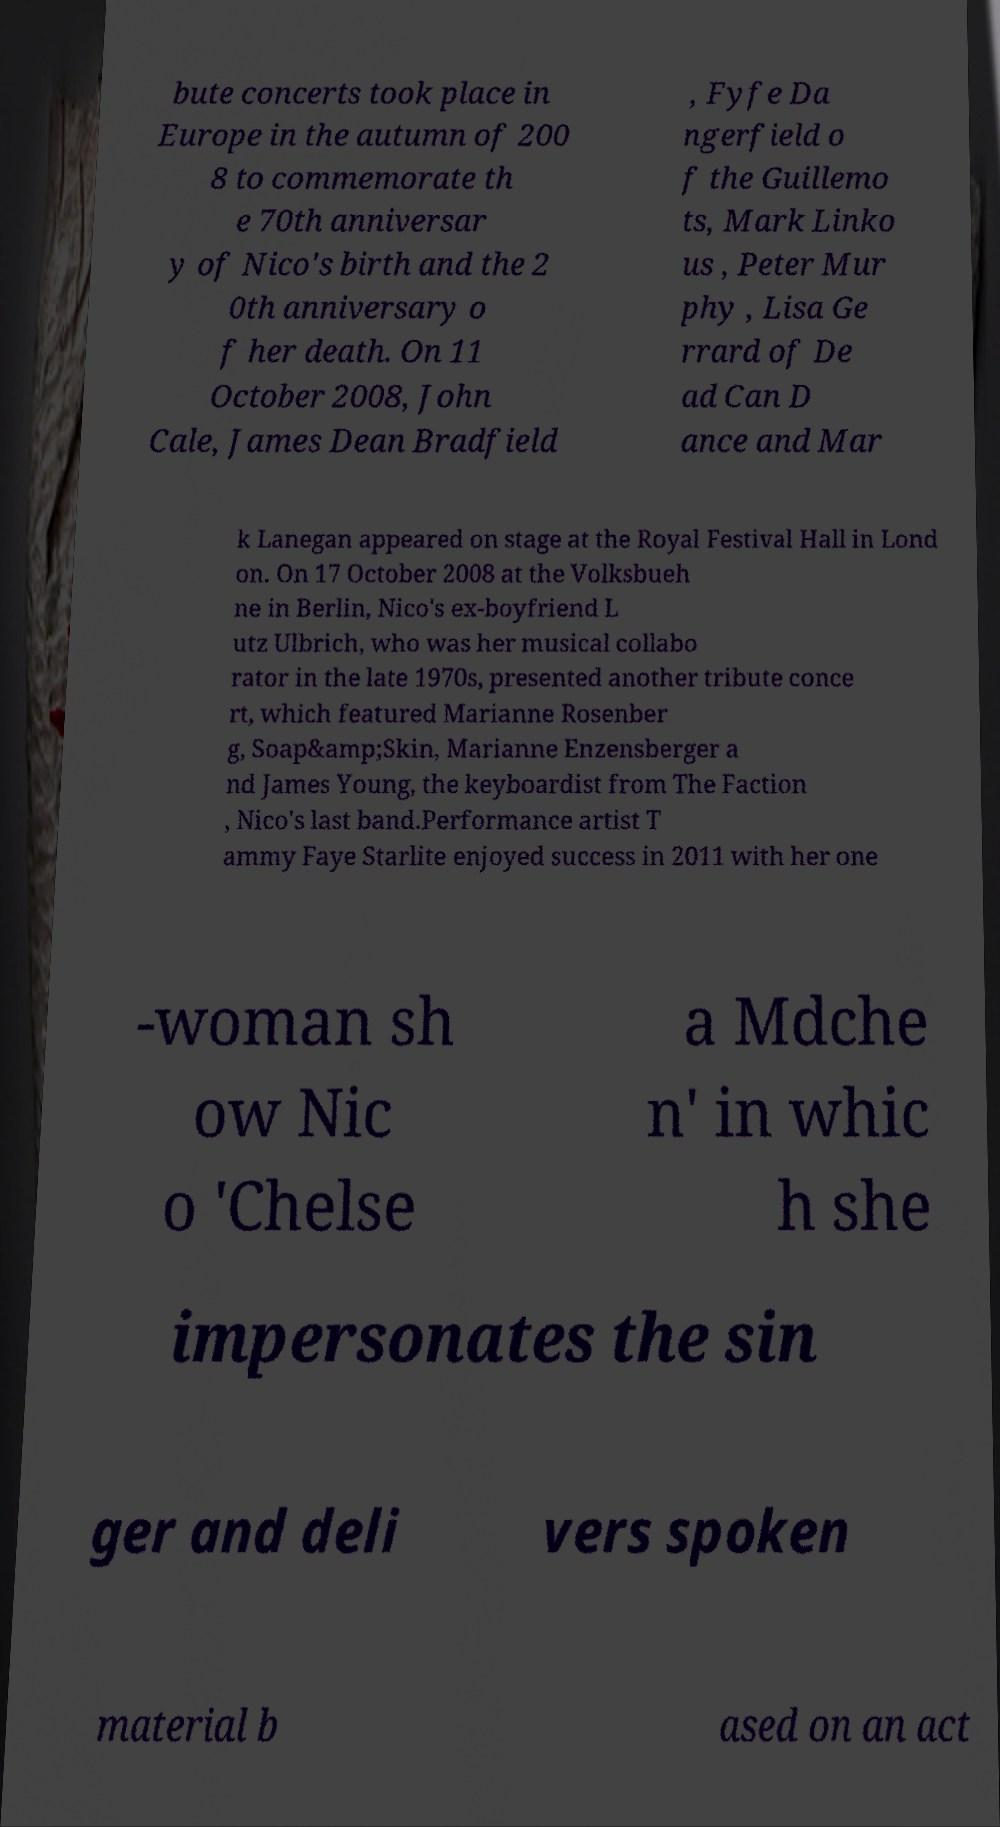Could you assist in decoding the text presented in this image and type it out clearly? bute concerts took place in Europe in the autumn of 200 8 to commemorate th e 70th anniversar y of Nico's birth and the 2 0th anniversary o f her death. On 11 October 2008, John Cale, James Dean Bradfield , Fyfe Da ngerfield o f the Guillemo ts, Mark Linko us , Peter Mur phy , Lisa Ge rrard of De ad Can D ance and Mar k Lanegan appeared on stage at the Royal Festival Hall in Lond on. On 17 October 2008 at the Volksbueh ne in Berlin, Nico's ex-boyfriend L utz Ulbrich, who was her musical collabo rator in the late 1970s, presented another tribute conce rt, which featured Marianne Rosenber g, Soap&amp;Skin, Marianne Enzensberger a nd James Young, the keyboardist from The Faction , Nico's last band.Performance artist T ammy Faye Starlite enjoyed success in 2011 with her one -woman sh ow Nic o 'Chelse a Mdche n' in whic h she impersonates the sin ger and deli vers spoken material b ased on an act 